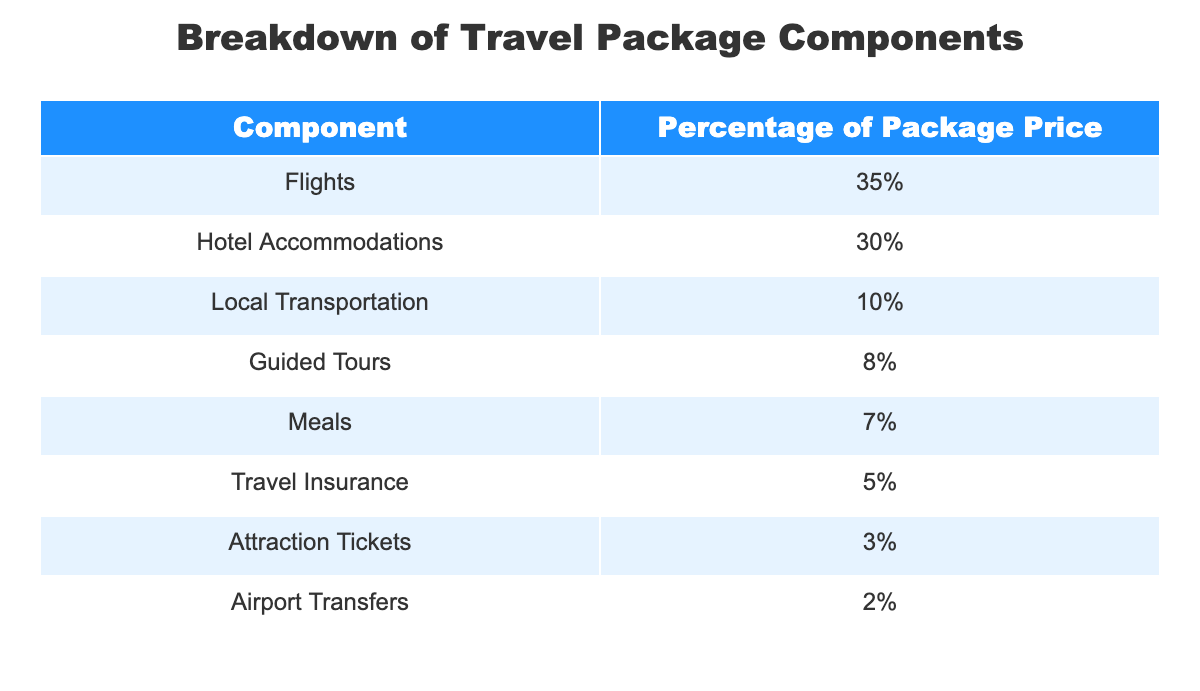What percentage of the package price is allocated to meals? The table indicates the percentage allocated to meals directly, which is listed under the "Meals" component. This shows that meals comprise 7% of the total package price.
Answer: 7% What is the combined percentage of local transportation and meals? To find the combined percentage, add the percentages of local transportation (10%) and meals (7%). Therefore, 10% + 7% equals 17%.
Answer: 17% Is the percentage for airport transfers more than 3%? The table shows that the percentage allocated for airport transfers is 2%. Since 2% is less than 3%, the answer is no.
Answer: No Which component receives the highest percentage of the package price? The components of the package price are listed, and flights are indicated as receiving the highest percentage at 35%, as it is the largest value in the table.
Answer: Flights What is the total percentage of the package price accounted for by guided tours and travel insurance? The percentage for guided tours is 8% and for travel insurance is 5%. Adding these together, 8% + 5% equals 13%.
Answer: 13% Is the percentage allocated for attraction tickets less than the percentage for meals? The percentage for attraction tickets is 3% and for meals, it's 7%. Since 3% is indeed less than 7%, the answer is yes.
Answer: Yes Which two components together make up the smallest portion of the package price? By reviewing the table, both airport transfers (2%) and attraction tickets (3%) together make up 5%, which is the smallest total when combining any two components from the table.
Answer: Airport Transfers and Attraction Tickets What percentage of the package price is accounted for by hotels and flights combined? The percentage for hotel accommodations is 30% and for flights is 35%. Adding these percentages together gives us 30% + 35% = 65%.
Answer: 65% 